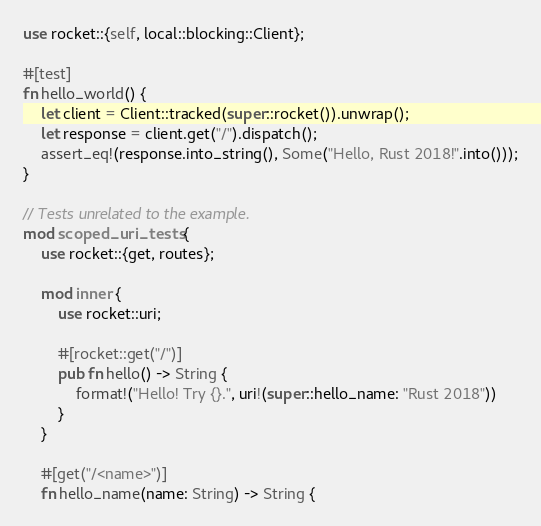Convert code to text. <code><loc_0><loc_0><loc_500><loc_500><_Rust_>use rocket::{self, local::blocking::Client};

#[test]
fn hello_world() {
    let client = Client::tracked(super::rocket()).unwrap();
    let response = client.get("/").dispatch();
    assert_eq!(response.into_string(), Some("Hello, Rust 2018!".into()));
}

// Tests unrelated to the example.
mod scoped_uri_tests {
    use rocket::{get, routes};

    mod inner {
        use rocket::uri;

        #[rocket::get("/")]
        pub fn hello() -> String {
            format!("Hello! Try {}.", uri!(super::hello_name: "Rust 2018"))
        }
    }

    #[get("/<name>")]
    fn hello_name(name: String) -> String {</code> 